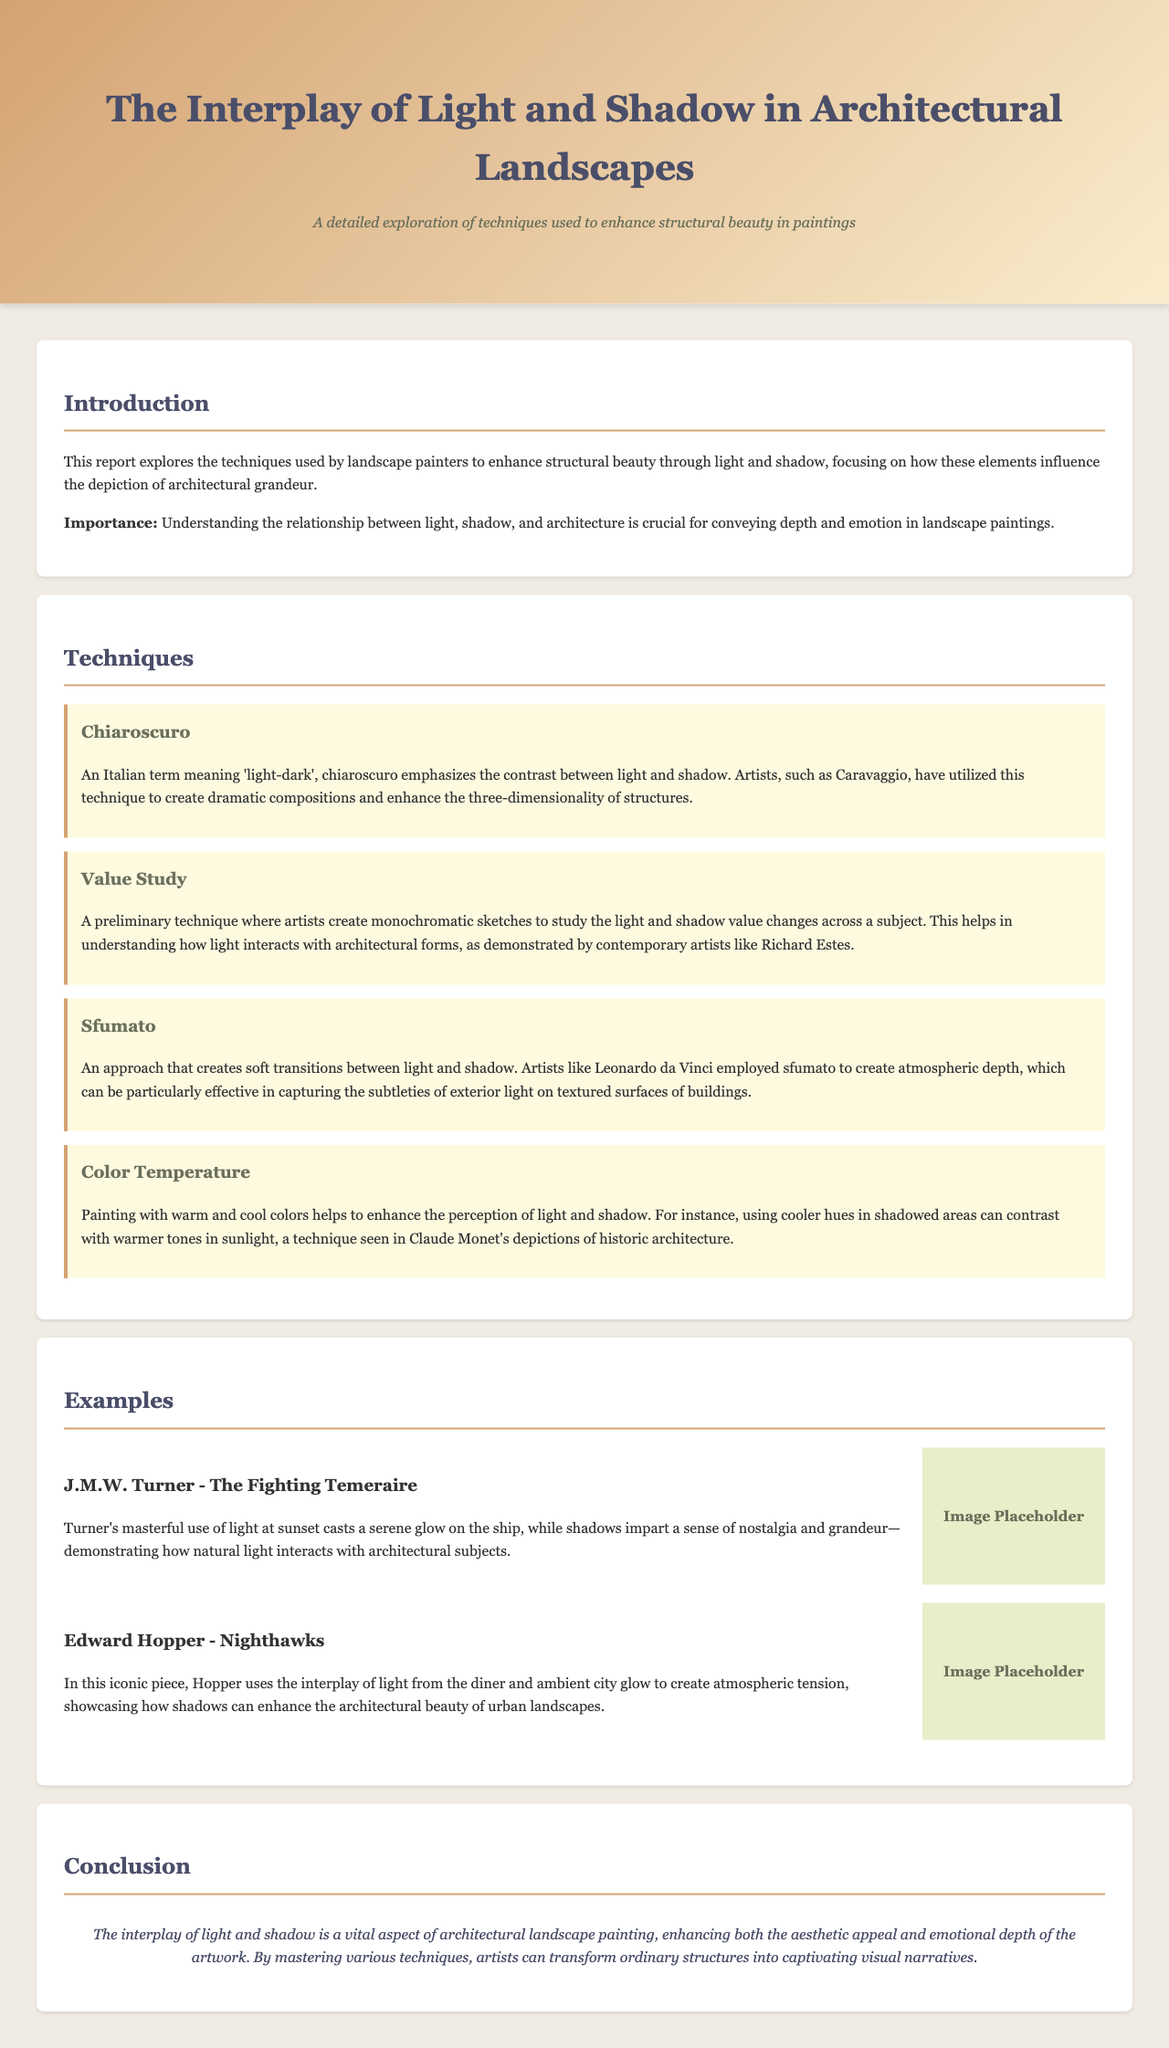What is the title of the report? The title is prominently displayed in the header of the document.
Answer: The Interplay of Light and Shadow in Architectural Landscapes What technique emphasizes contrast between light and shadow? This technique is discussed in the "Techniques" section of the document.
Answer: Chiaroscuro Which artist is known for using the technique of sfumato? This is mentioned in the description of the sfumato technique.
Answer: Leonardo da Vinci What is the significance of understanding light and shadow in landscape paintings? The importance is highlighted in the introduction section of the document.
Answer: Conveying depth and emotion How many techniques are discussed in the document? The techniques section lists each technique used in paintings.
Answer: Four Which artwork used light to cast a serene glow? This artwork is illustrated in the examples section.
Answer: The Fighting Temeraire Who created the piece Nighthawks? The artist is referenced alongside the example provided in the document.
Answer: Edward Hopper What color temperature technique is mentioned in the document? This is specifically described in the techniques section.
Answer: Warm and cool colors 